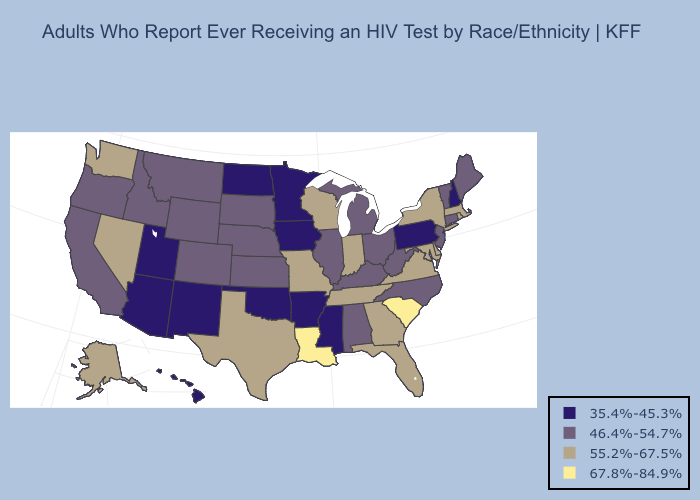Name the states that have a value in the range 35.4%-45.3%?
Write a very short answer. Arizona, Arkansas, Hawaii, Iowa, Minnesota, Mississippi, New Hampshire, New Mexico, North Dakota, Oklahoma, Pennsylvania, Utah. Which states have the highest value in the USA?
Keep it brief. Louisiana, South Carolina. Name the states that have a value in the range 67.8%-84.9%?
Concise answer only. Louisiana, South Carolina. Name the states that have a value in the range 55.2%-67.5%?
Answer briefly. Alaska, Delaware, Florida, Georgia, Indiana, Maryland, Massachusetts, Missouri, Nevada, New York, Rhode Island, Tennessee, Texas, Virginia, Washington, Wisconsin. Does Michigan have a lower value than New York?
Quick response, please. Yes. Name the states that have a value in the range 67.8%-84.9%?
Quick response, please. Louisiana, South Carolina. Name the states that have a value in the range 55.2%-67.5%?
Write a very short answer. Alaska, Delaware, Florida, Georgia, Indiana, Maryland, Massachusetts, Missouri, Nevada, New York, Rhode Island, Tennessee, Texas, Virginia, Washington, Wisconsin. What is the lowest value in states that border South Carolina?
Be succinct. 46.4%-54.7%. Does Colorado have the lowest value in the USA?
Concise answer only. No. Name the states that have a value in the range 46.4%-54.7%?
Be succinct. Alabama, California, Colorado, Connecticut, Idaho, Illinois, Kansas, Kentucky, Maine, Michigan, Montana, Nebraska, New Jersey, North Carolina, Ohio, Oregon, South Dakota, Vermont, West Virginia, Wyoming. Does the map have missing data?
Keep it brief. No. What is the value of Delaware?
Concise answer only. 55.2%-67.5%. Name the states that have a value in the range 55.2%-67.5%?
Keep it brief. Alaska, Delaware, Florida, Georgia, Indiana, Maryland, Massachusetts, Missouri, Nevada, New York, Rhode Island, Tennessee, Texas, Virginia, Washington, Wisconsin. What is the lowest value in states that border Oklahoma?
Write a very short answer. 35.4%-45.3%. Name the states that have a value in the range 55.2%-67.5%?
Quick response, please. Alaska, Delaware, Florida, Georgia, Indiana, Maryland, Massachusetts, Missouri, Nevada, New York, Rhode Island, Tennessee, Texas, Virginia, Washington, Wisconsin. 